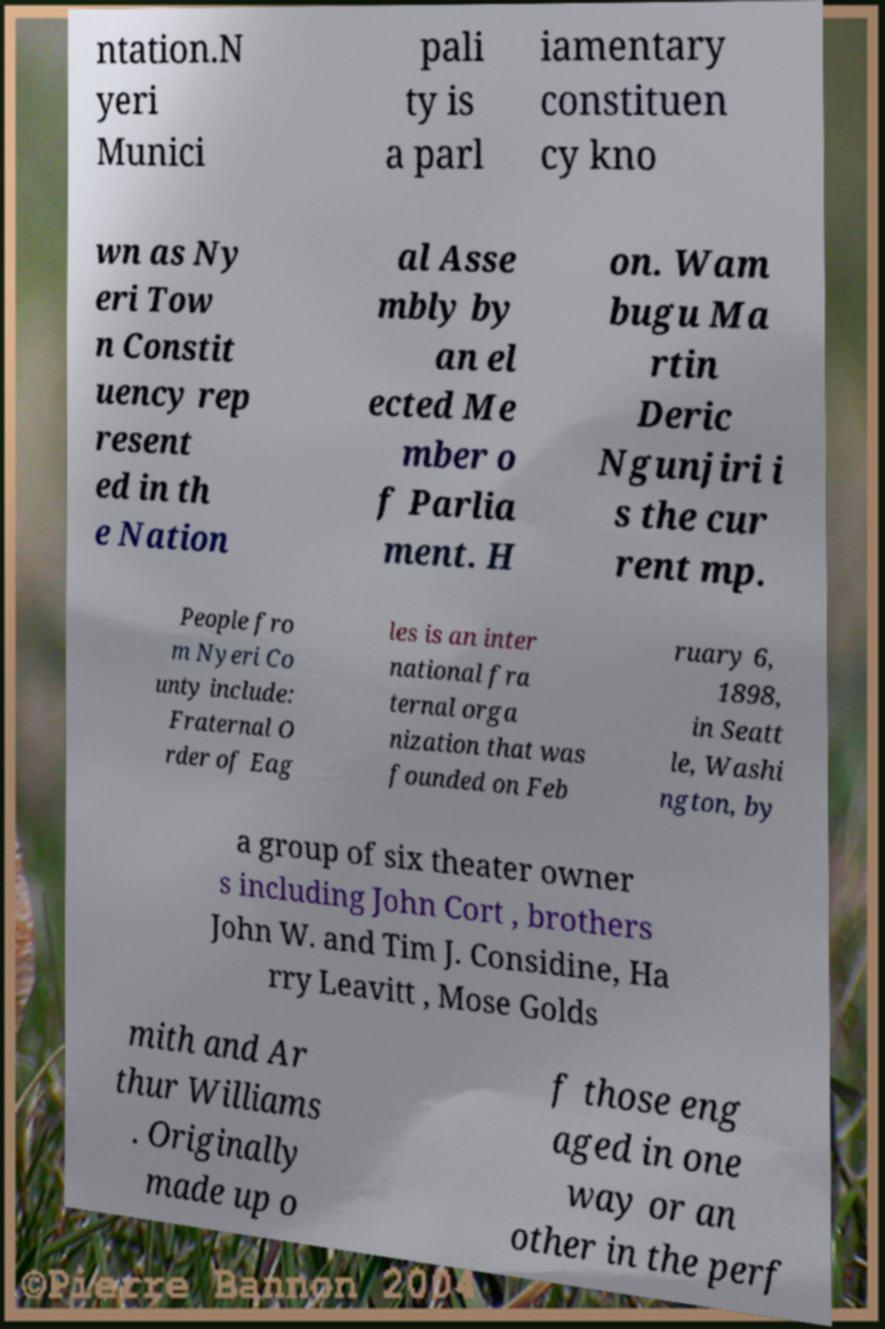I need the written content from this picture converted into text. Can you do that? ntation.N yeri Munici pali ty is a parl iamentary constituen cy kno wn as Ny eri Tow n Constit uency rep resent ed in th e Nation al Asse mbly by an el ected Me mber o f Parlia ment. H on. Wam bugu Ma rtin Deric Ngunjiri i s the cur rent mp. People fro m Nyeri Co unty include: Fraternal O rder of Eag les is an inter national fra ternal orga nization that was founded on Feb ruary 6, 1898, in Seatt le, Washi ngton, by a group of six theater owner s including John Cort , brothers John W. and Tim J. Considine, Ha rry Leavitt , Mose Golds mith and Ar thur Williams . Originally made up o f those eng aged in one way or an other in the perf 